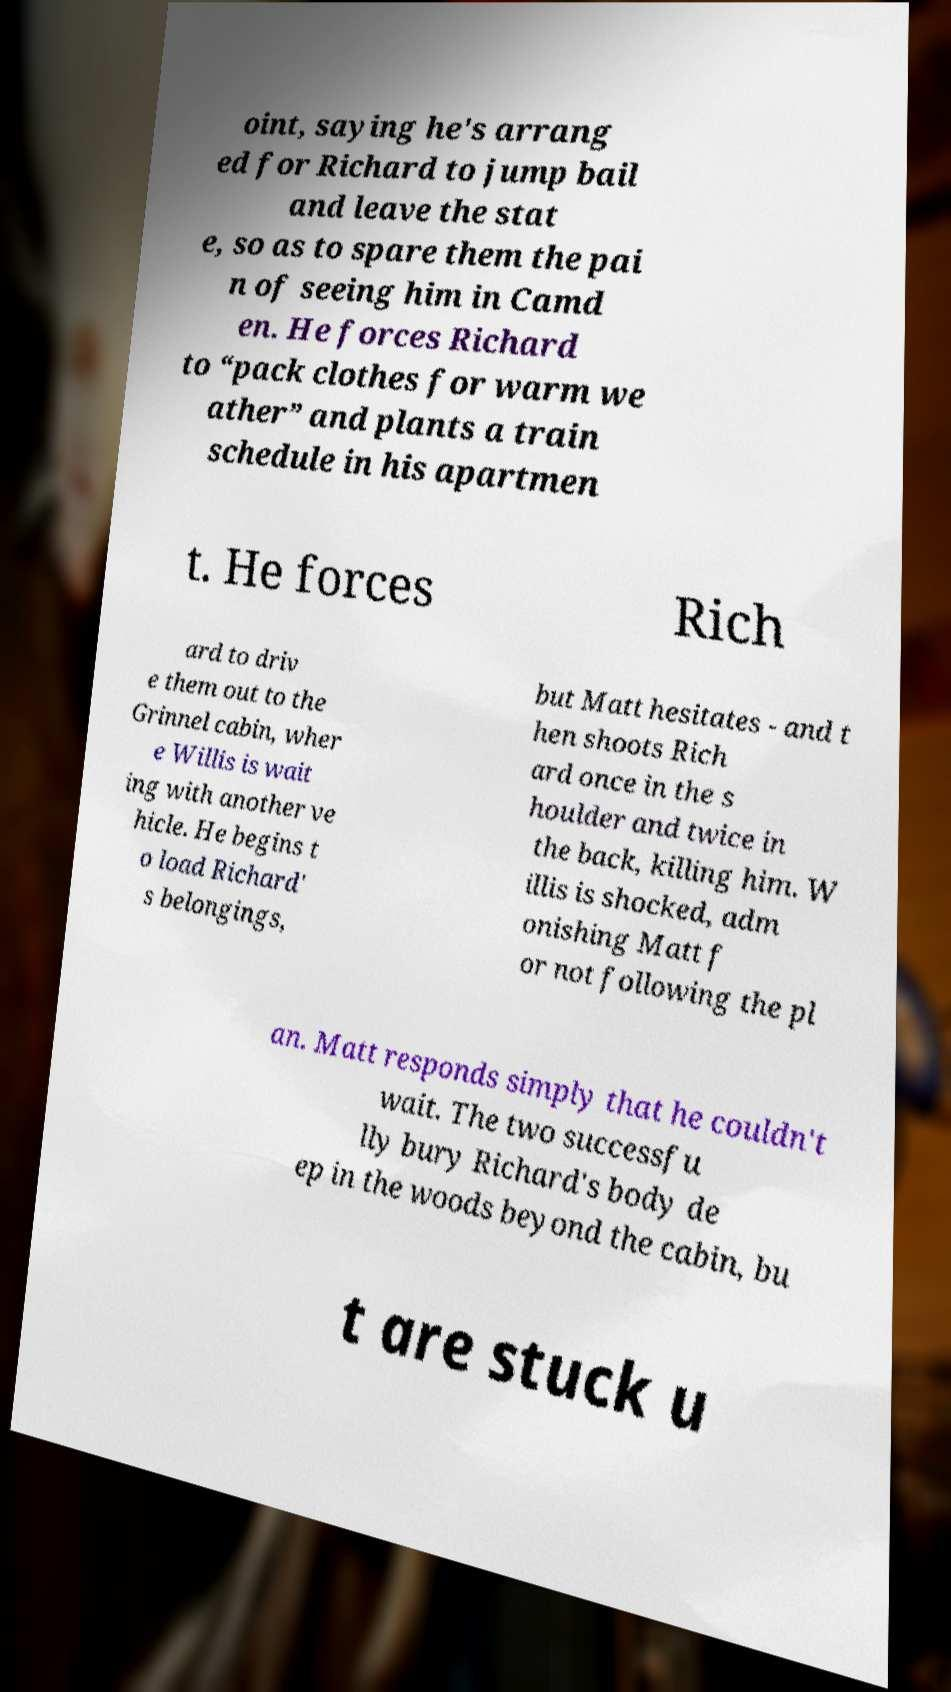There's text embedded in this image that I need extracted. Can you transcribe it verbatim? oint, saying he's arrang ed for Richard to jump bail and leave the stat e, so as to spare them the pai n of seeing him in Camd en. He forces Richard to “pack clothes for warm we ather” and plants a train schedule in his apartmen t. He forces Rich ard to driv e them out to the Grinnel cabin, wher e Willis is wait ing with another ve hicle. He begins t o load Richard' s belongings, but Matt hesitates - and t hen shoots Rich ard once in the s houlder and twice in the back, killing him. W illis is shocked, adm onishing Matt f or not following the pl an. Matt responds simply that he couldn't wait. The two successfu lly bury Richard's body de ep in the woods beyond the cabin, bu t are stuck u 